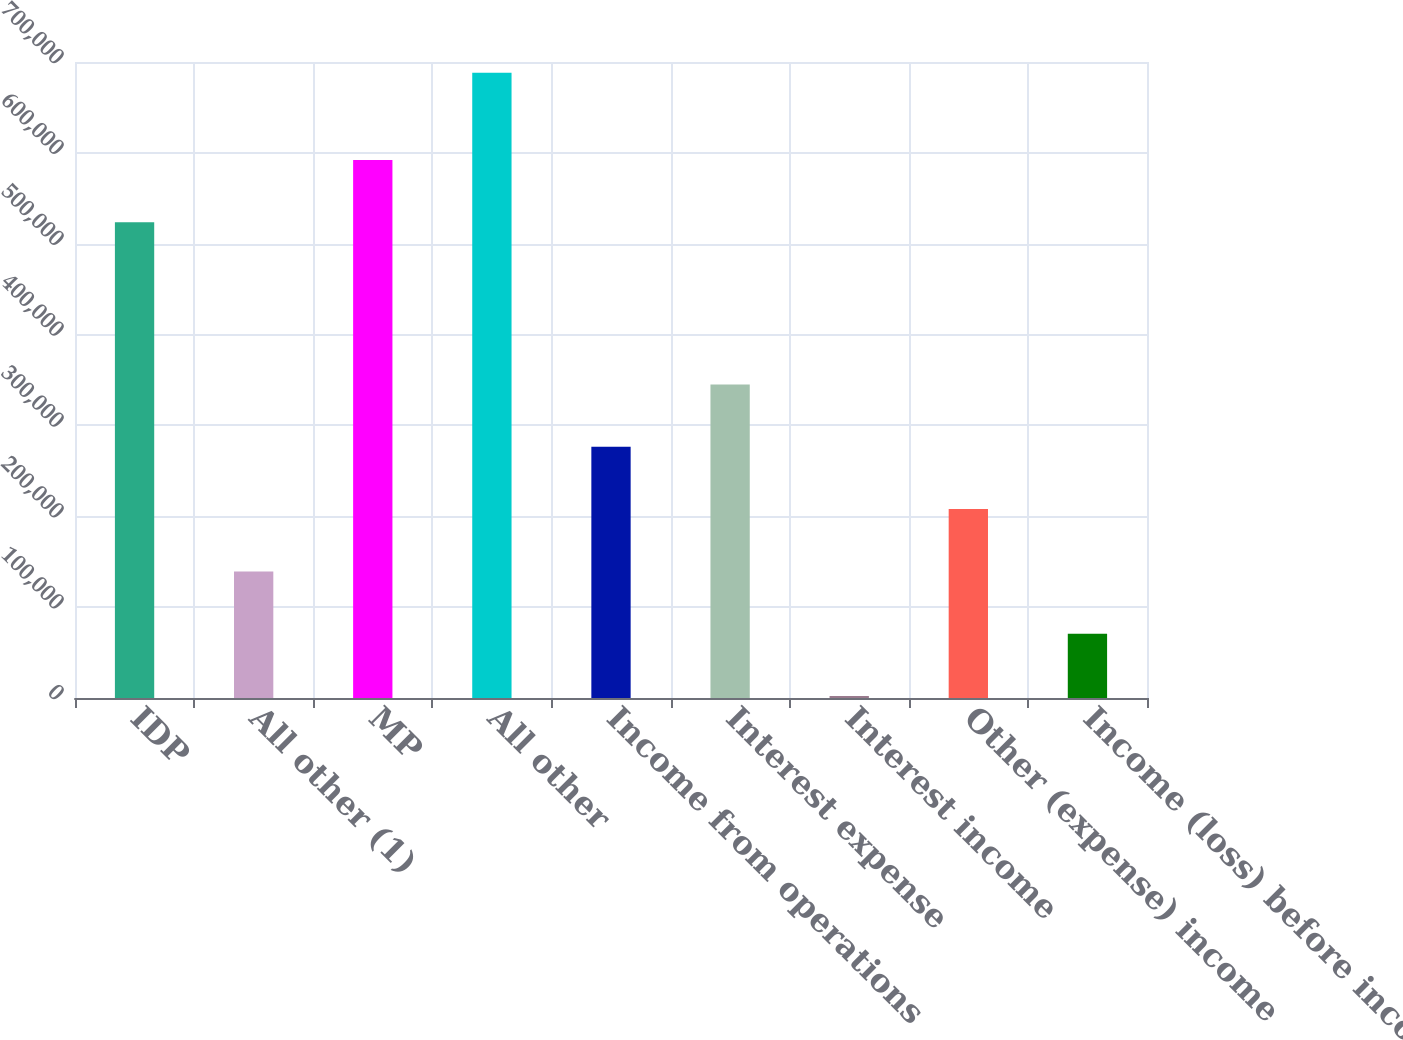<chart> <loc_0><loc_0><loc_500><loc_500><bar_chart><fcel>IDP<fcel>All other (1)<fcel>MP<fcel>All other<fcel>Income from operations<fcel>Interest expense<fcel>Interest income<fcel>Other (expense) income<fcel>Income (loss) before income<nl><fcel>523512<fcel>139285<fcel>592120<fcel>688153<fcel>276502<fcel>345110<fcel>2068<fcel>207894<fcel>70676.5<nl></chart> 